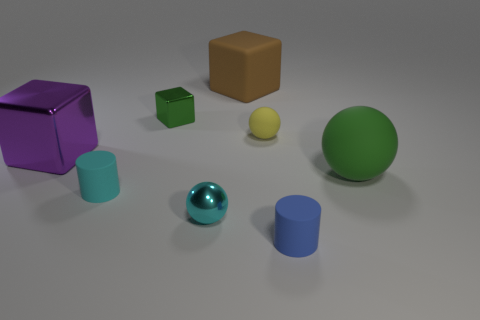Is the color of the tiny metallic block the same as the big ball?
Your answer should be very brief. Yes. Does the large sphere have the same color as the small shiny thing that is behind the big rubber sphere?
Make the answer very short. Yes. What number of matte cylinders have the same color as the tiny shiny sphere?
Your response must be concise. 1. The green thing that is made of the same material as the tiny cyan ball is what shape?
Provide a short and direct response. Cube. What is the size of the brown rubber object that is the same shape as the small green thing?
Your answer should be very brief. Large. Are there any small cyan things left of the small blue rubber object?
Your answer should be compact. Yes. Are there the same number of large purple blocks left of the tiny metal sphere and green matte balls?
Your answer should be very brief. Yes. Is there a metallic object behind the tiny metallic object behind the tiny sphere that is in front of the yellow object?
Keep it short and to the point. No. What material is the large green object?
Your response must be concise. Rubber. How many other objects are there of the same shape as the cyan metallic object?
Offer a terse response. 2. 